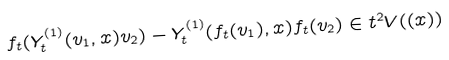<formula> <loc_0><loc_0><loc_500><loc_500>f _ { t } ( Y ^ { ( 1 ) } _ { t } ( v _ { 1 } , x ) v _ { 2 } ) - Y ^ { ( 1 ) } _ { t } ( f _ { t } ( v _ { 1 } ) , x ) f _ { t } ( v _ { 2 } ) \in t ^ { 2 } V ( ( x ) )</formula> 